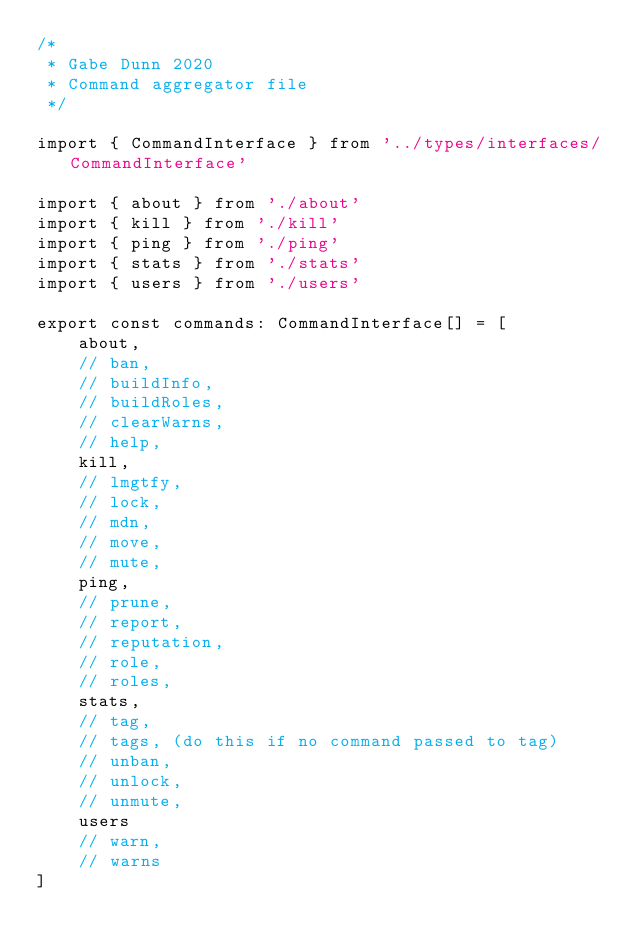<code> <loc_0><loc_0><loc_500><loc_500><_TypeScript_>/*
 * Gabe Dunn 2020
 * Command aggregator file
 */

import { CommandInterface } from '../types/interfaces/CommandInterface'

import { about } from './about'
import { kill } from './kill'
import { ping } from './ping'
import { stats } from './stats'
import { users } from './users'

export const commands: CommandInterface[] = [
    about,
    // ban,
    // buildInfo,
    // buildRoles,
    // clearWarns,
    // help,
    kill,
    // lmgtfy,
    // lock,
    // mdn,
    // move,
    // mute,
    ping,
    // prune,
    // report,
    // reputation,
    // role,
    // roles,
    stats,
    // tag,
    // tags, (do this if no command passed to tag)
    // unban,
    // unlock,
    // unmute,
    users
    // warn,
    // warns
]
</code> 